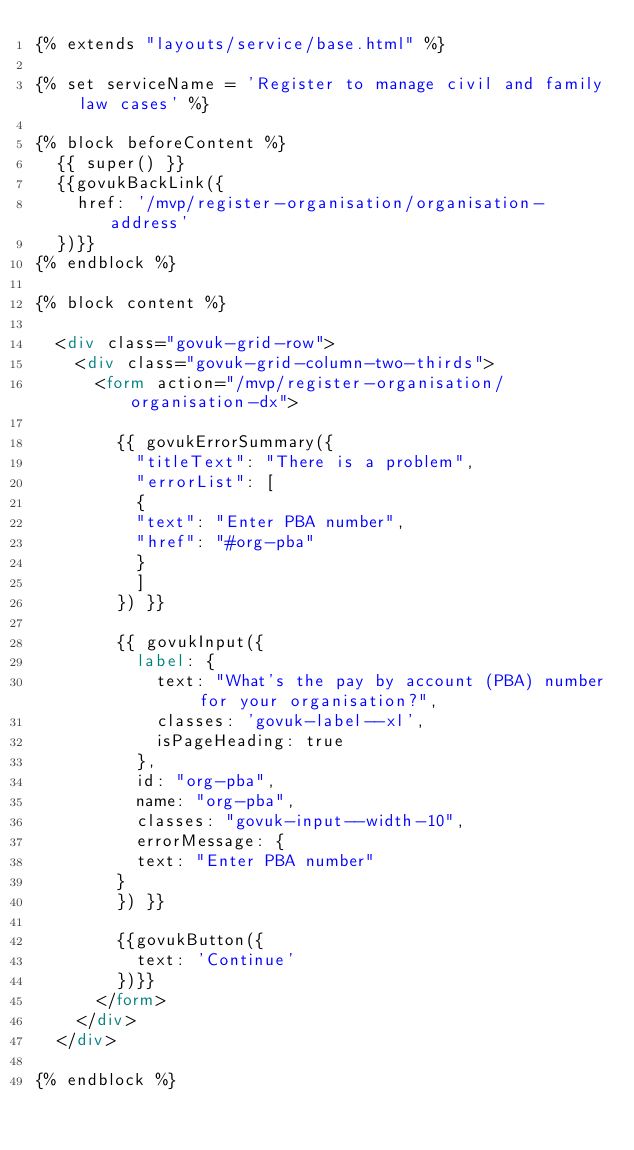<code> <loc_0><loc_0><loc_500><loc_500><_HTML_>{% extends "layouts/service/base.html" %}

{% set serviceName = 'Register to manage civil and family law cases' %}

{% block beforeContent %}
  {{ super() }}
  {{govukBackLink({
    href: '/mvp/register-organisation/organisation-address'
  })}}
{% endblock %}

{% block content %}

  <div class="govuk-grid-row">
    <div class="govuk-grid-column-two-thirds">
      <form action="/mvp/register-organisation/organisation-dx">

        {{ govukErrorSummary({
          "titleText": "There is a problem",
          "errorList": [
          {
          "text": "Enter PBA number",
          "href": "#org-pba"
          }
          ]
        }) }}

        {{ govukInput({
          label: {
            text: "What's the pay by account (PBA) number for your organisation?",
            classes: 'govuk-label--xl',
            isPageHeading: true
          },
          id: "org-pba",
          name: "org-pba",
          classes: "govuk-input--width-10",
          errorMessage: {
          text: "Enter PBA number"
        }
        }) }}

        {{govukButton({
          text: 'Continue'
        })}}
      </form>
    </div>
  </div>

{% endblock %}
</code> 